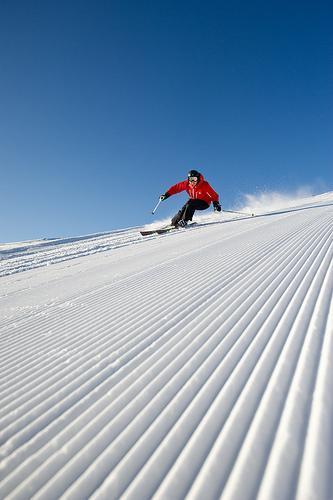How many ski poles are there?
Give a very brief answer. 2. How many people are there?
Give a very brief answer. 1. 